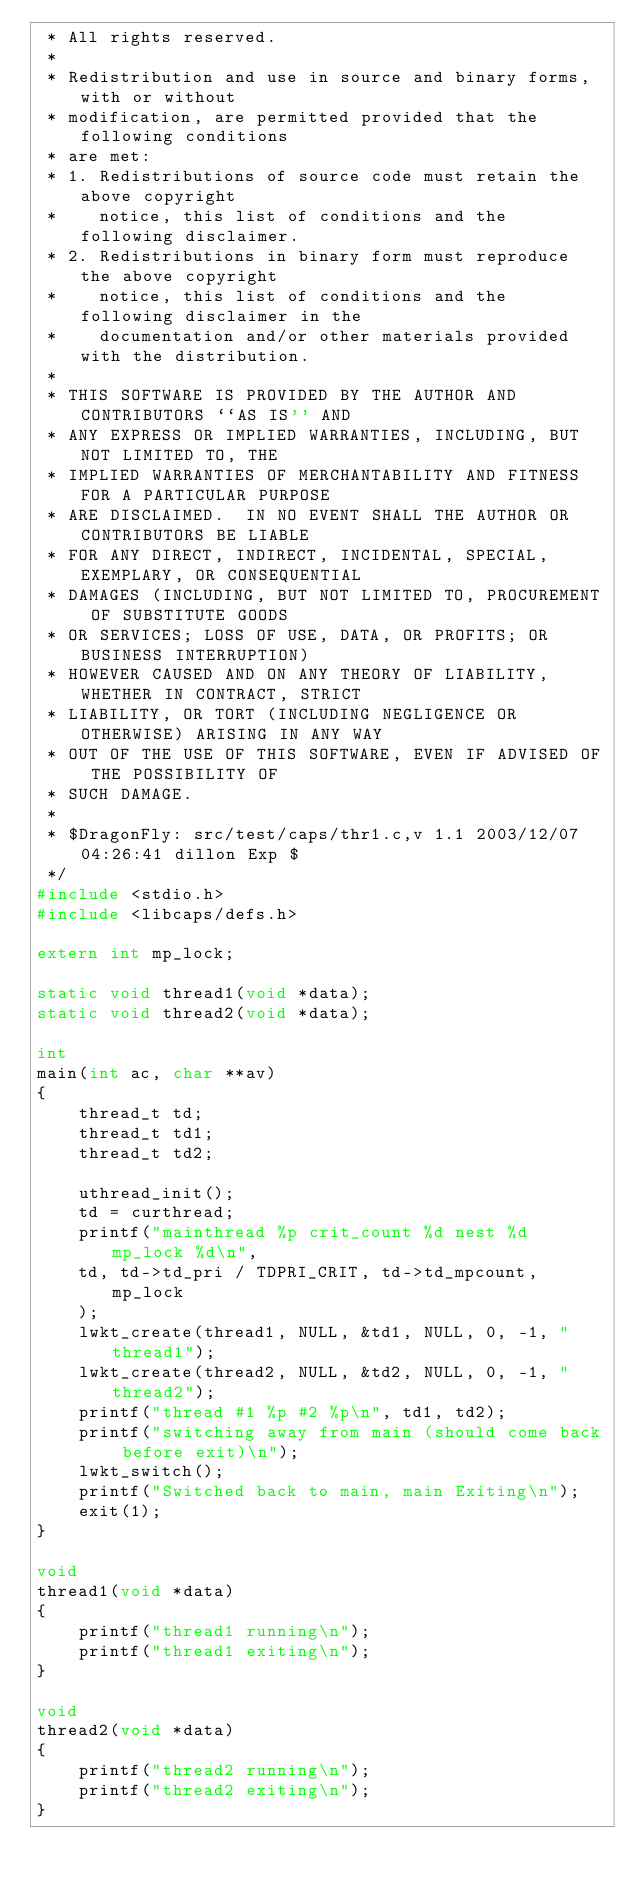Convert code to text. <code><loc_0><loc_0><loc_500><loc_500><_C_> * All rights reserved.
 *
 * Redistribution and use in source and binary forms, with or without
 * modification, are permitted provided that the following conditions
 * are met:
 * 1. Redistributions of source code must retain the above copyright
 *    notice, this list of conditions and the following disclaimer.
 * 2. Redistributions in binary form must reproduce the above copyright
 *    notice, this list of conditions and the following disclaimer in the
 *    documentation and/or other materials provided with the distribution.
 *
 * THIS SOFTWARE IS PROVIDED BY THE AUTHOR AND CONTRIBUTORS ``AS IS'' AND
 * ANY EXPRESS OR IMPLIED WARRANTIES, INCLUDING, BUT NOT LIMITED TO, THE
 * IMPLIED WARRANTIES OF MERCHANTABILITY AND FITNESS FOR A PARTICULAR PURPOSE
 * ARE DISCLAIMED.  IN NO EVENT SHALL THE AUTHOR OR CONTRIBUTORS BE LIABLE
 * FOR ANY DIRECT, INDIRECT, INCIDENTAL, SPECIAL, EXEMPLARY, OR CONSEQUENTIAL
 * DAMAGES (INCLUDING, BUT NOT LIMITED TO, PROCUREMENT OF SUBSTITUTE GOODS
 * OR SERVICES; LOSS OF USE, DATA, OR PROFITS; OR BUSINESS INTERRUPTION)
 * HOWEVER CAUSED AND ON ANY THEORY OF LIABILITY, WHETHER IN CONTRACT, STRICT
 * LIABILITY, OR TORT (INCLUDING NEGLIGENCE OR OTHERWISE) ARISING IN ANY WAY
 * OUT OF THE USE OF THIS SOFTWARE, EVEN IF ADVISED OF THE POSSIBILITY OF
 * SUCH DAMAGE.
 *
 * $DragonFly: src/test/caps/thr1.c,v 1.1 2003/12/07 04:26:41 dillon Exp $
 */
#include <stdio.h>
#include <libcaps/defs.h>

extern int mp_lock;

static void thread1(void *data);
static void thread2(void *data);

int
main(int ac, char **av)
{
    thread_t td;
    thread_t td1;
    thread_t td2;

    uthread_init();
    td = curthread;
    printf("mainthread %p crit_count %d nest %d mp_lock %d\n", 
	td, td->td_pri / TDPRI_CRIT, td->td_mpcount, mp_lock
    );
    lwkt_create(thread1, NULL, &td1, NULL, 0, -1, "thread1");
    lwkt_create(thread2, NULL, &td2, NULL, 0, -1, "thread2");
    printf("thread #1 %p #2 %p\n", td1, td2);
    printf("switching away from main (should come back before exit)\n");
    lwkt_switch();
    printf("Switched back to main, main Exiting\n");
    exit(1);
}

void
thread1(void *data)
{
    printf("thread1 running\n");
    printf("thread1 exiting\n");
}

void
thread2(void *data)
{
    printf("thread2 running\n");
    printf("thread2 exiting\n");
}

</code> 